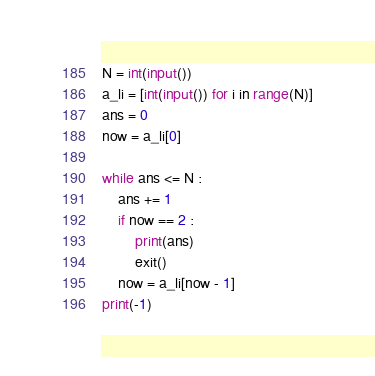Convert code to text. <code><loc_0><loc_0><loc_500><loc_500><_Python_>N = int(input())
a_li = [int(input()) for i in range(N)]
ans = 0
now = a_li[0]

while ans <= N :
    ans += 1
    if now == 2 :
        print(ans)
        exit()
    now = a_li[now - 1]
print(-1)
</code> 